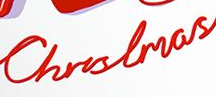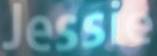What text appears in these images from left to right, separated by a semicolon? Christmas; Jessie 